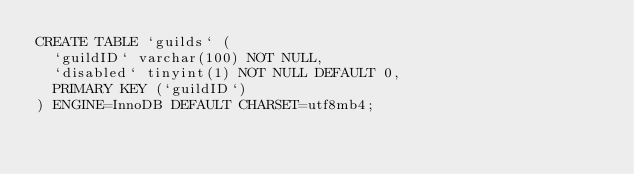<code> <loc_0><loc_0><loc_500><loc_500><_SQL_>CREATE TABLE `guilds` (
  `guildID` varchar(100) NOT NULL,
  `disabled` tinyint(1) NOT NULL DEFAULT 0,
  PRIMARY KEY (`guildID`)
) ENGINE=InnoDB DEFAULT CHARSET=utf8mb4;</code> 